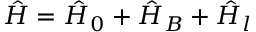<formula> <loc_0><loc_0><loc_500><loc_500>\hat { H } = \hat { H } _ { 0 } + \hat { H } _ { B } + \hat { H } _ { l }</formula> 